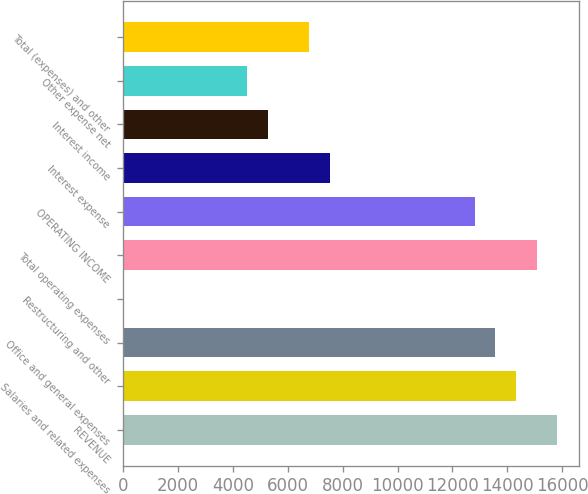Convert chart. <chart><loc_0><loc_0><loc_500><loc_500><bar_chart><fcel>REVENUE<fcel>Salaries and related expenses<fcel>Office and general expenses<fcel>Restructuring and other<fcel>Total operating expenses<fcel>OPERATING INCOME<fcel>Interest expense<fcel>Interest income<fcel>Other expense net<fcel>Total (expenses) and other<nl><fcel>15827.7<fcel>14320.3<fcel>13566.6<fcel>0.2<fcel>15074<fcel>12812.9<fcel>7537.1<fcel>5276.03<fcel>4522.34<fcel>6783.41<nl></chart> 